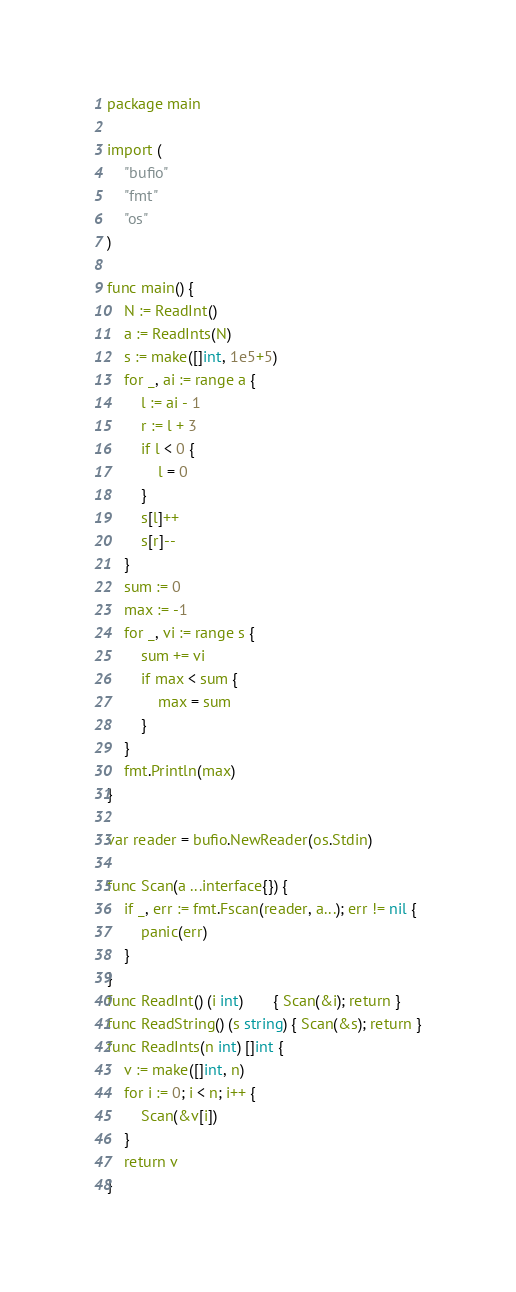Convert code to text. <code><loc_0><loc_0><loc_500><loc_500><_Go_>package main

import (
	"bufio"
	"fmt"
	"os"
)

func main() {
	N := ReadInt()
	a := ReadInts(N)
	s := make([]int, 1e5+5)
	for _, ai := range a {
		l := ai - 1
		r := l + 3
		if l < 0 {
			l = 0
		}
		s[l]++
		s[r]--
	}
	sum := 0
	max := -1
	for _, vi := range s {
		sum += vi
		if max < sum {
			max = sum
		}
	}
	fmt.Println(max)
}

var reader = bufio.NewReader(os.Stdin)

func Scan(a ...interface{}) {
	if _, err := fmt.Fscan(reader, a...); err != nil {
		panic(err)
	}
}
func ReadInt() (i int)       { Scan(&i); return }
func ReadString() (s string) { Scan(&s); return }
func ReadInts(n int) []int {
	v := make([]int, n)
	for i := 0; i < n; i++ {
		Scan(&v[i])
	}
	return v
}
</code> 